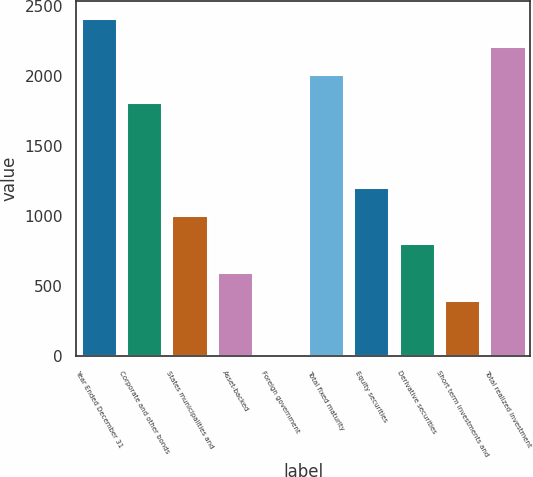Convert chart to OTSL. <chart><loc_0><loc_0><loc_500><loc_500><bar_chart><fcel>Year Ended December 31<fcel>Corporate and other bonds<fcel>States municipalities and<fcel>Asset-backed<fcel>Foreign government<fcel>Total fixed maturity<fcel>Equity securities<fcel>Derivative securities<fcel>Short term investments and<fcel>Total realized investment<nl><fcel>2417.8<fcel>1813.6<fcel>1008<fcel>605.2<fcel>1<fcel>2015<fcel>1209.4<fcel>806.6<fcel>403.8<fcel>2216.4<nl></chart> 